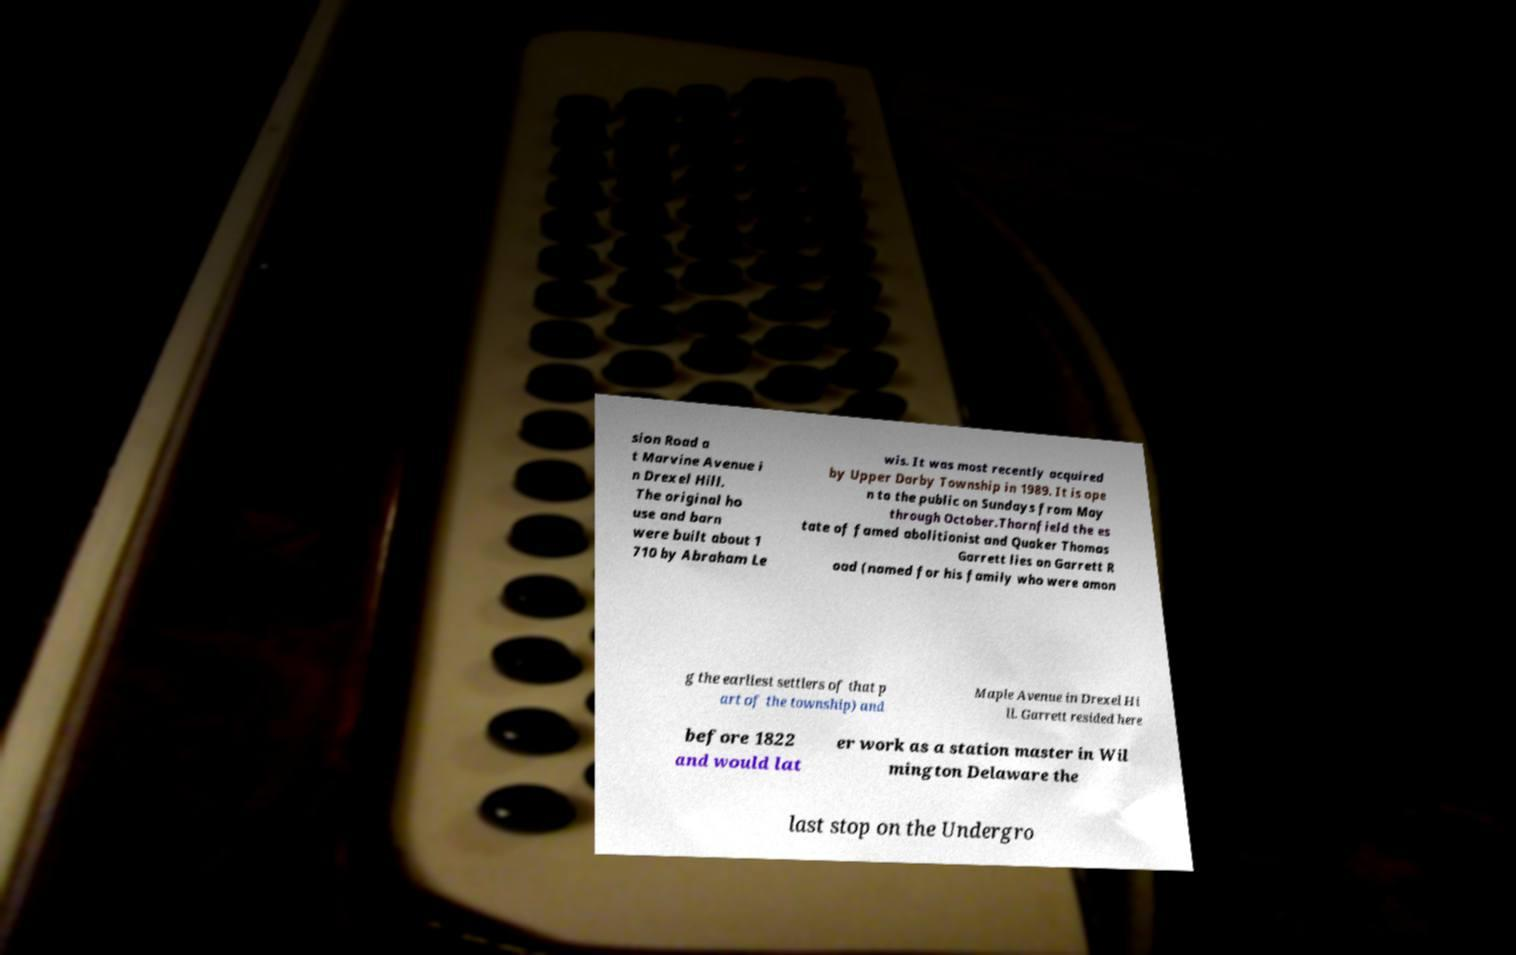There's text embedded in this image that I need extracted. Can you transcribe it verbatim? sion Road a t Marvine Avenue i n Drexel Hill. The original ho use and barn were built about 1 710 by Abraham Le wis. It was most recently acquired by Upper Darby Township in 1989. It is ope n to the public on Sundays from May through October.Thornfield the es tate of famed abolitionist and Quaker Thomas Garrett lies on Garrett R oad (named for his family who were amon g the earliest settlers of that p art of the township) and Maple Avenue in Drexel Hi ll. Garrett resided here before 1822 and would lat er work as a station master in Wil mington Delaware the last stop on the Undergro 